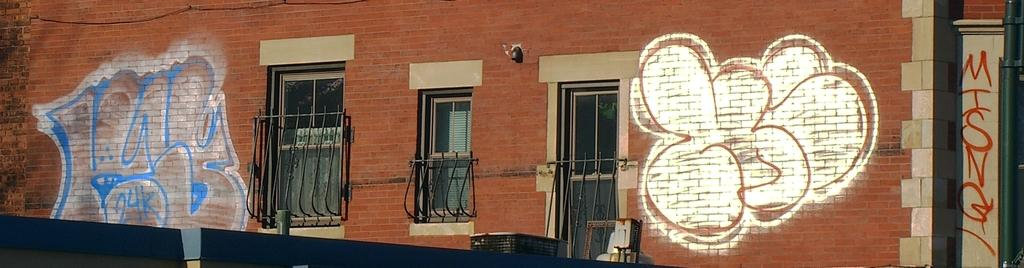What is the main subject in the center of the image? There is a building in the center of the image. What feature can be seen on the building? The building has windows. How many cattle are grazing in front of the building in the image? There are no cattle present in the image; it only features a building with windows. What type of hook can be seen hanging from the building in the image? There is no hook visible in the image; it only features a building with windows. 